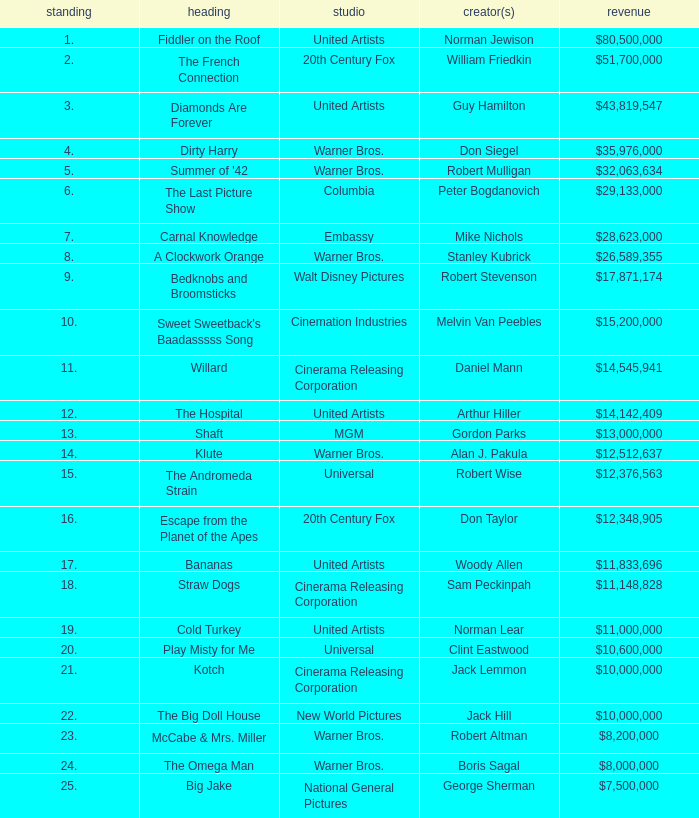Which title ranked lower than 19 has a gross of $11,833,696? Bananas. 